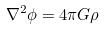<formula> <loc_0><loc_0><loc_500><loc_500>\nabla ^ { 2 } \phi = 4 \pi G \rho</formula> 